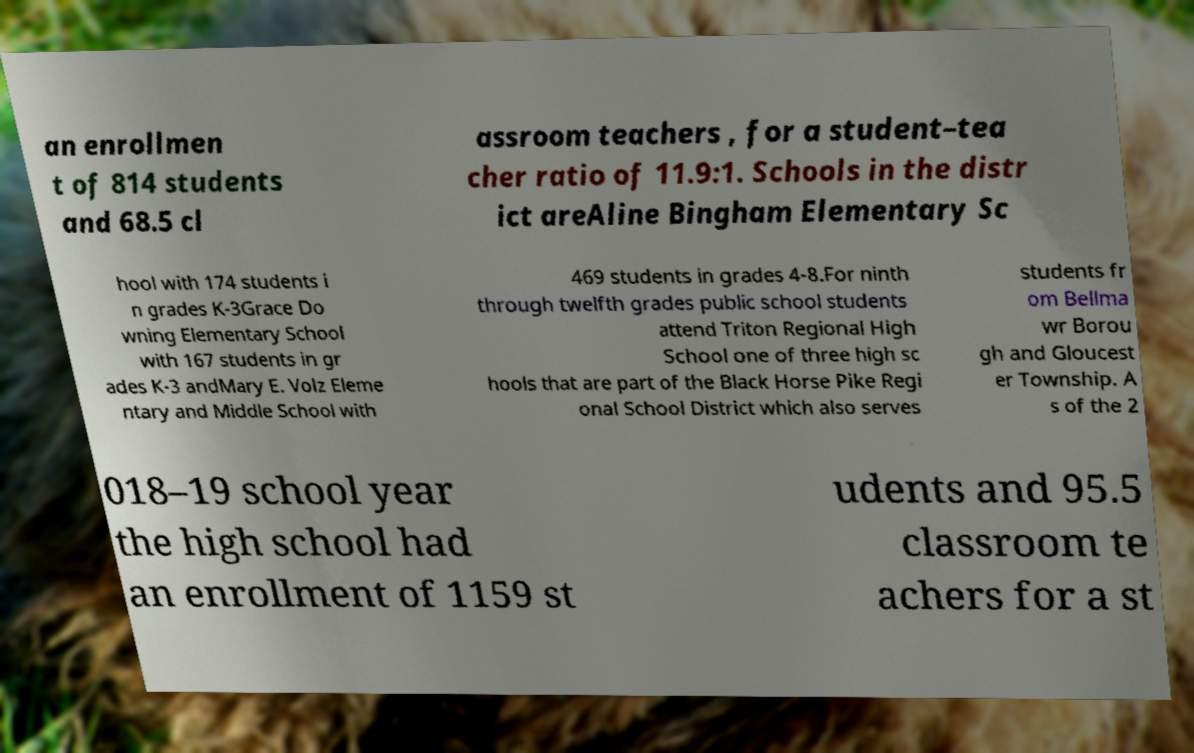Please identify and transcribe the text found in this image. an enrollmen t of 814 students and 68.5 cl assroom teachers , for a student–tea cher ratio of 11.9:1. Schools in the distr ict areAline Bingham Elementary Sc hool with 174 students i n grades K-3Grace Do wning Elementary School with 167 students in gr ades K-3 andMary E. Volz Eleme ntary and Middle School with 469 students in grades 4-8.For ninth through twelfth grades public school students attend Triton Regional High School one of three high sc hools that are part of the Black Horse Pike Regi onal School District which also serves students fr om Bellma wr Borou gh and Gloucest er Township. A s of the 2 018–19 school year the high school had an enrollment of 1159 st udents and 95.5 classroom te achers for a st 